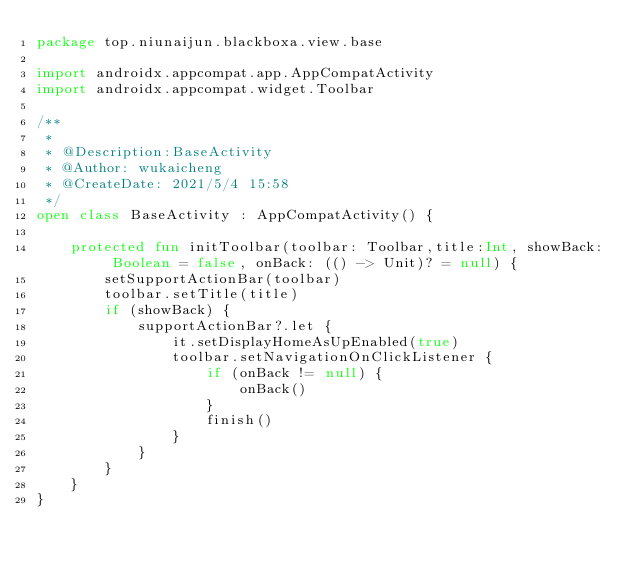<code> <loc_0><loc_0><loc_500><loc_500><_Kotlin_>package top.niunaijun.blackboxa.view.base

import androidx.appcompat.app.AppCompatActivity
import androidx.appcompat.widget.Toolbar

/**
 *
 * @Description:BaseActivity
 * @Author: wukaicheng
 * @CreateDate: 2021/5/4 15:58
 */
open class BaseActivity : AppCompatActivity() {

    protected fun initToolbar(toolbar: Toolbar,title:Int, showBack: Boolean = false, onBack: (() -> Unit)? = null) {
        setSupportActionBar(toolbar)
        toolbar.setTitle(title)
        if (showBack) {
            supportActionBar?.let {
                it.setDisplayHomeAsUpEnabled(true)
                toolbar.setNavigationOnClickListener {
                    if (onBack != null) {
                        onBack()
                    }
                    finish()
                }
            }
        }
    }
}</code> 